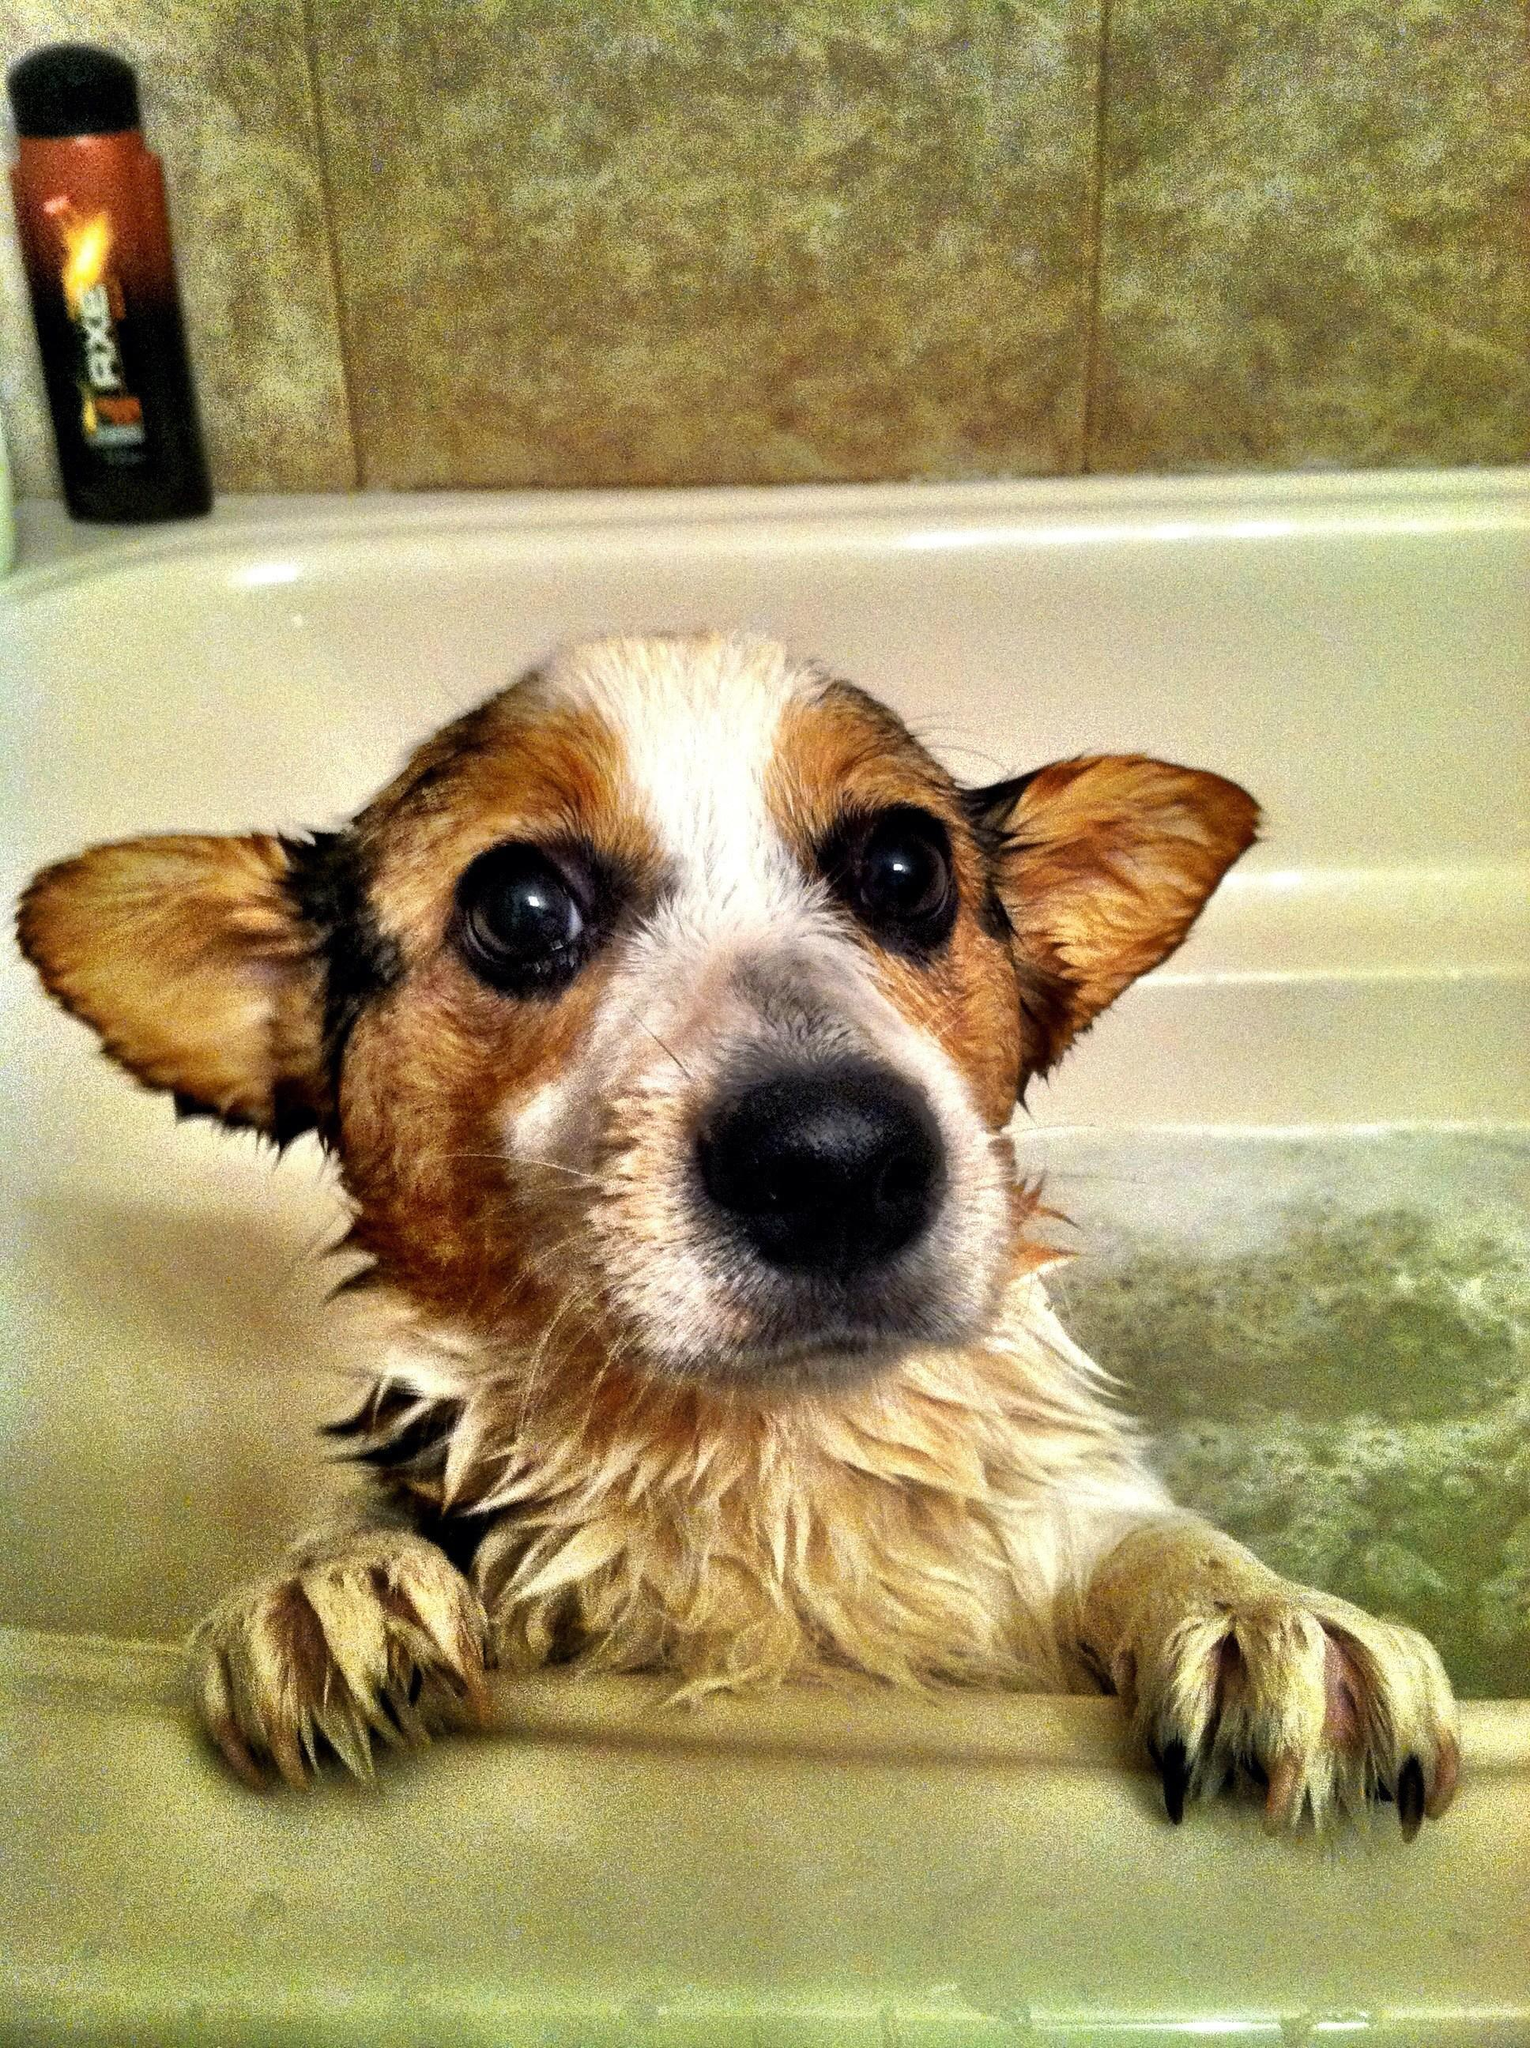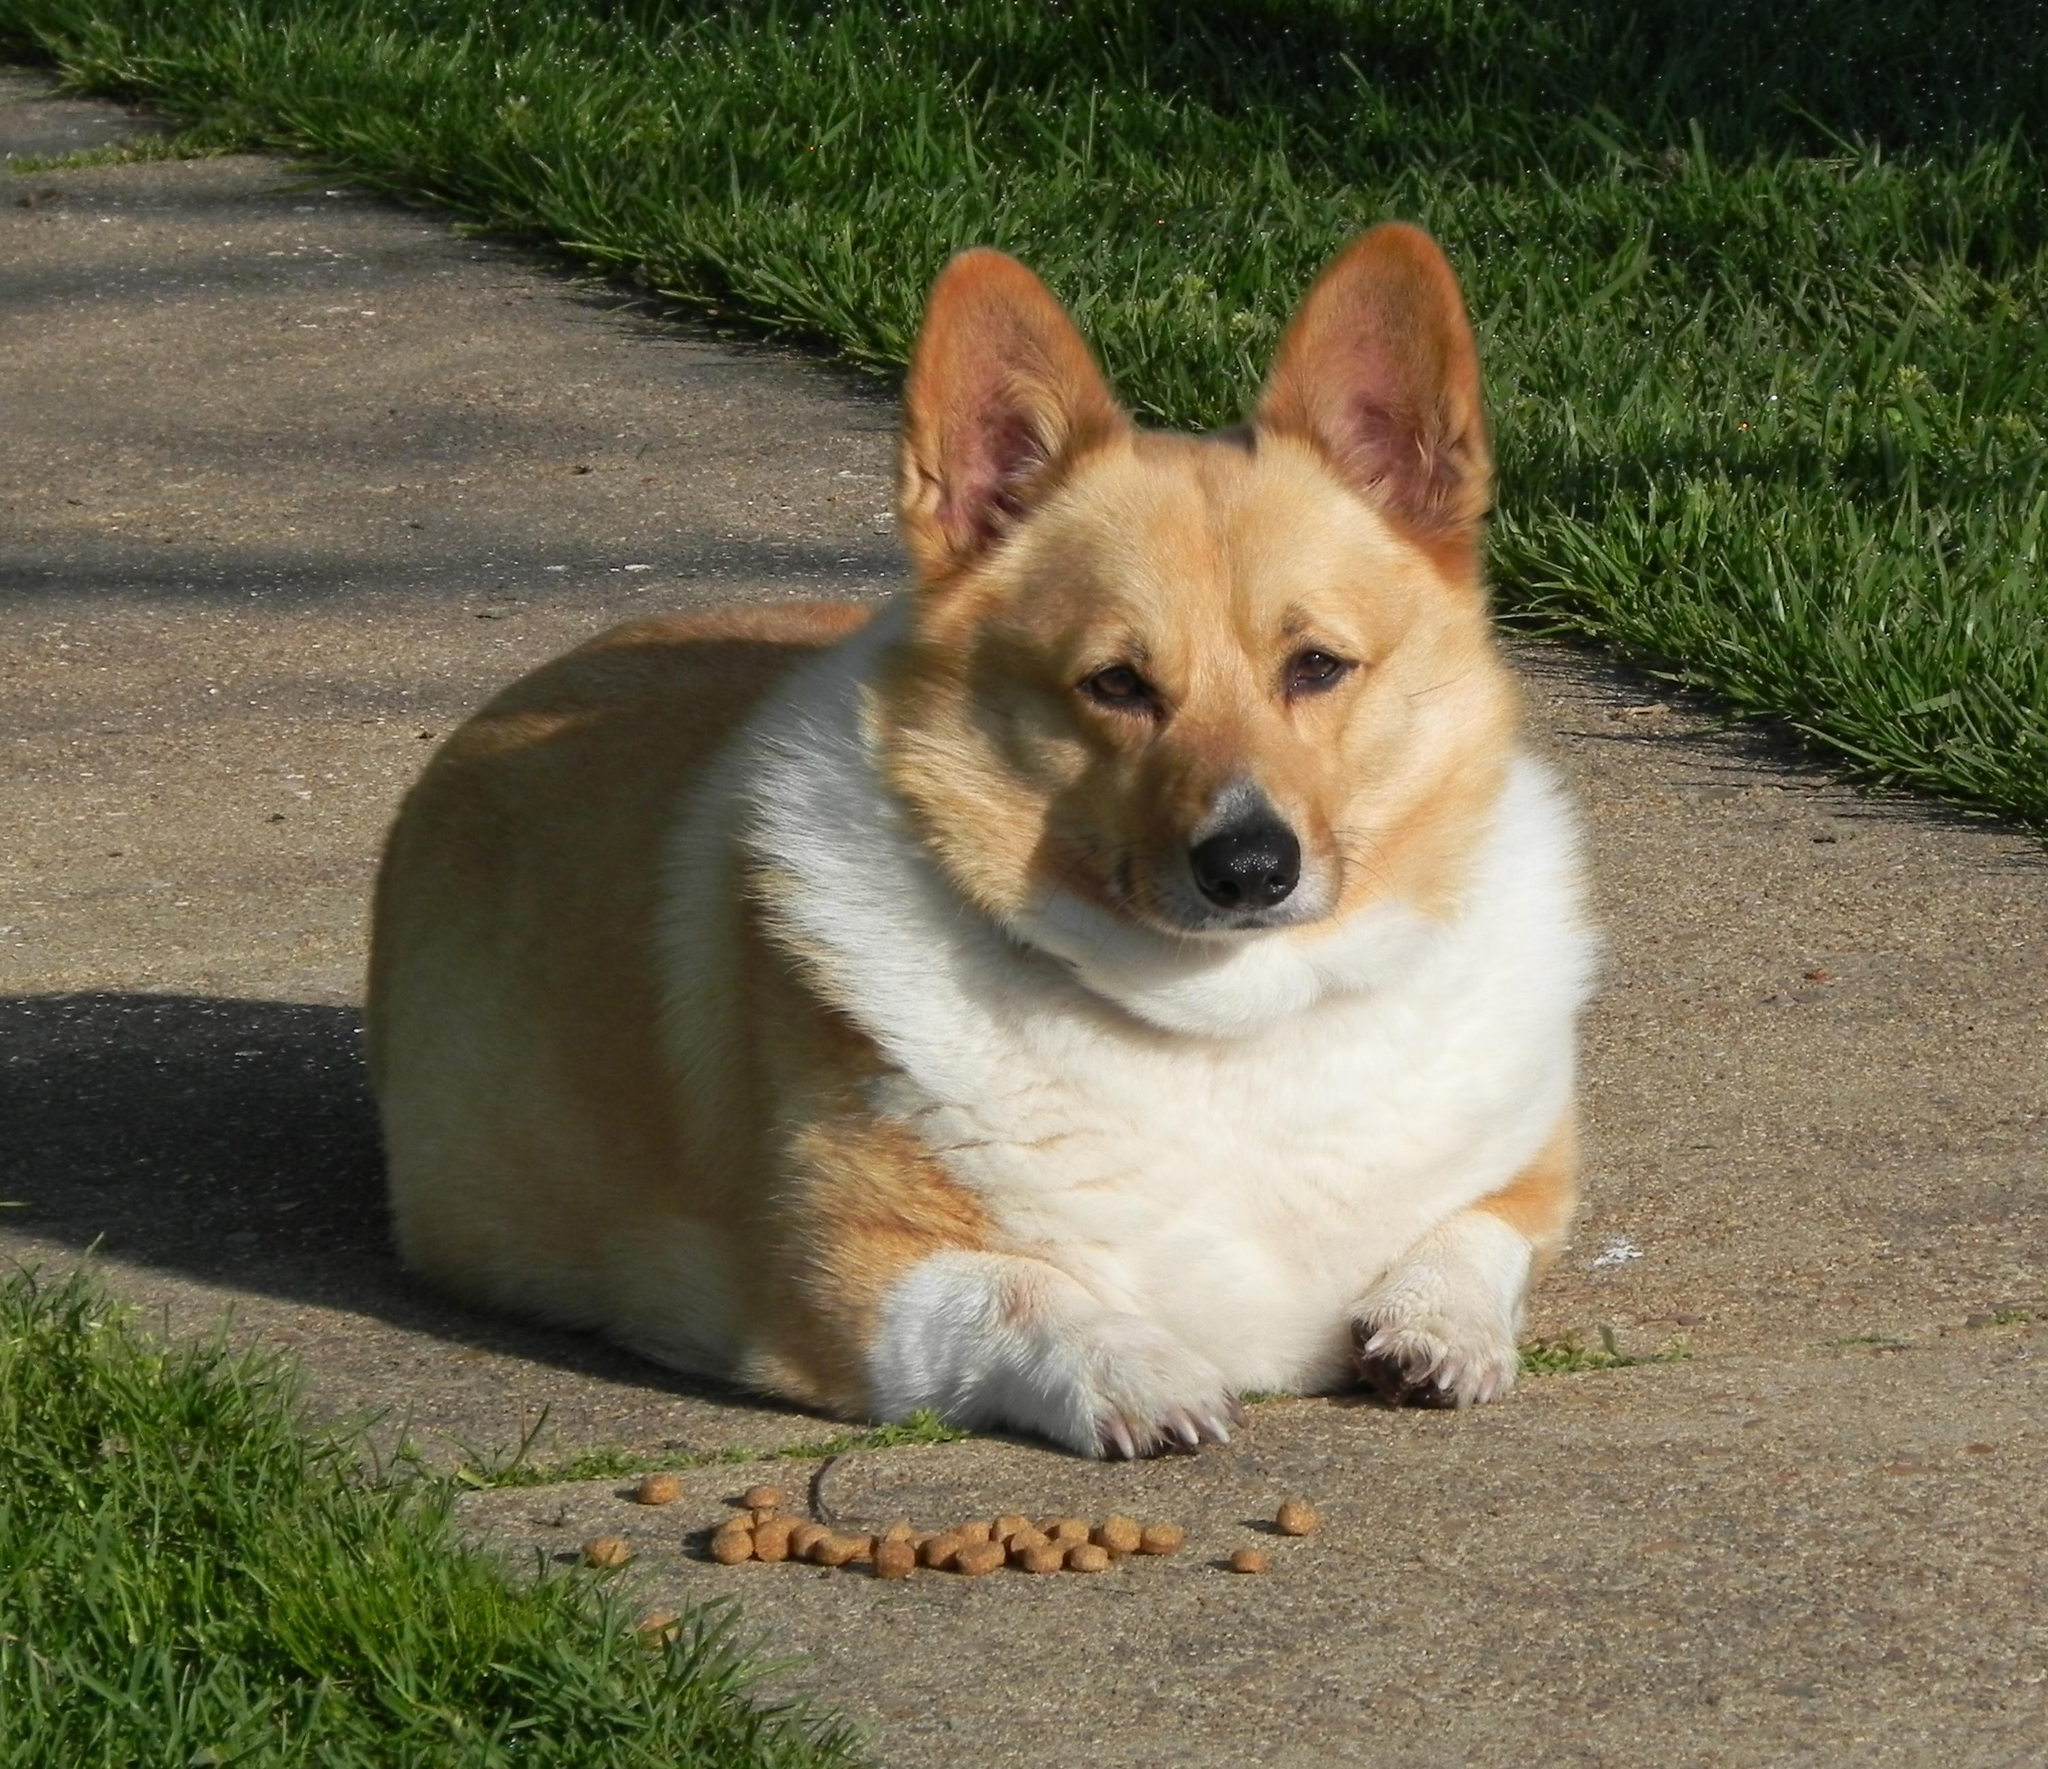The first image is the image on the left, the second image is the image on the right. Considering the images on both sides, is "The left image shows a corgi sitting on green grass behind a mound of pale dog fir." valid? Answer yes or no. No. The first image is the image on the left, the second image is the image on the right. Considering the images on both sides, is "The dog in the image on the right has its mouth open." valid? Answer yes or no. No. 